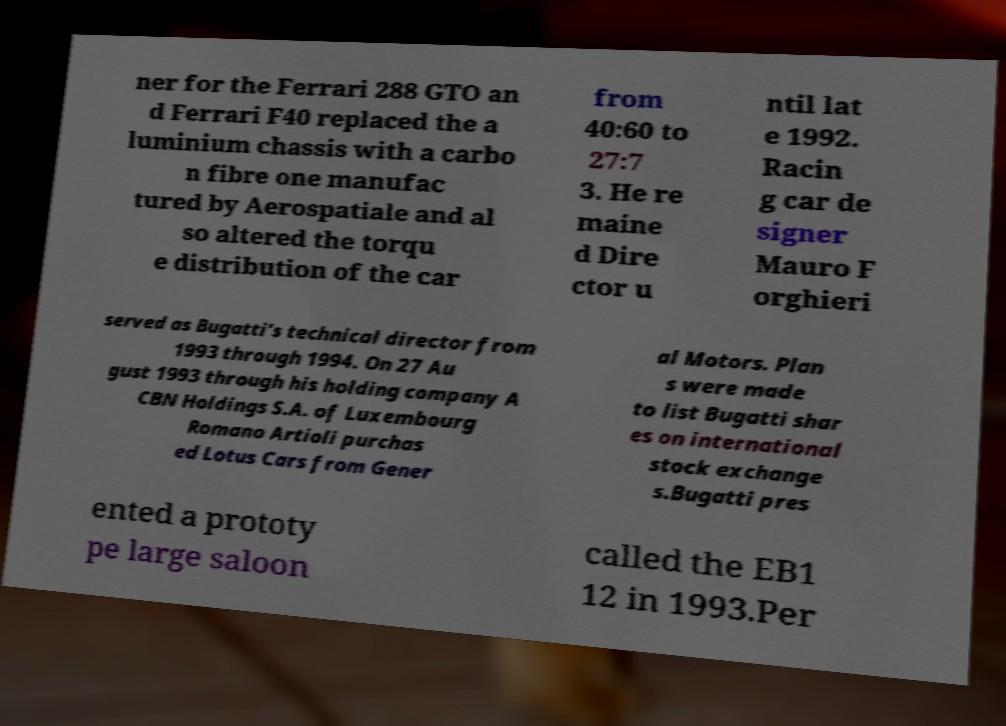Can you accurately transcribe the text from the provided image for me? ner for the Ferrari 288 GTO an d Ferrari F40 replaced the a luminium chassis with a carbo n fibre one manufac tured by Aerospatiale and al so altered the torqu e distribution of the car from 40:60 to 27:7 3. He re maine d Dire ctor u ntil lat e 1992. Racin g car de signer Mauro F orghieri served as Bugatti's technical director from 1993 through 1994. On 27 Au gust 1993 through his holding company A CBN Holdings S.A. of Luxembourg Romano Artioli purchas ed Lotus Cars from Gener al Motors. Plan s were made to list Bugatti shar es on international stock exchange s.Bugatti pres ented a prototy pe large saloon called the EB1 12 in 1993.Per 